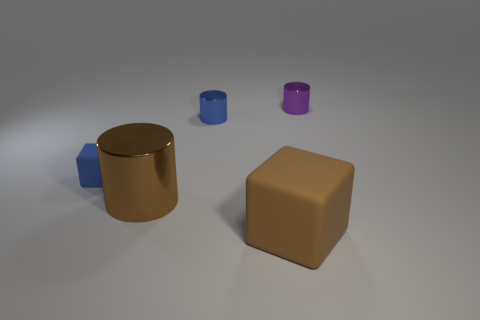What is the color of the tiny thing that is the same material as the big cube?
Your answer should be very brief. Blue. Does the large cylinder have the same color as the rubber object right of the blue metallic thing?
Your answer should be compact. Yes. What is the color of the tiny object that is both right of the small block and to the left of the purple thing?
Provide a succinct answer. Blue. What number of brown cubes are to the right of the big brown rubber object?
Provide a short and direct response. 0. How many objects are either red shiny cylinders or objects that are in front of the brown shiny cylinder?
Offer a very short reply. 1. Are there any small purple cylinders on the left side of the tiny thing that is to the left of the brown shiny object?
Give a very brief answer. No. What color is the cube on the left side of the big brown shiny cylinder?
Offer a terse response. Blue. Are there the same number of purple metal cylinders that are left of the blue shiny cylinder and large blue matte objects?
Your answer should be compact. Yes. There is a shiny thing that is to the left of the big brown matte object and behind the big brown cylinder; what is its shape?
Make the answer very short. Cylinder. What color is the other tiny object that is the same shape as the purple shiny thing?
Ensure brevity in your answer.  Blue. 